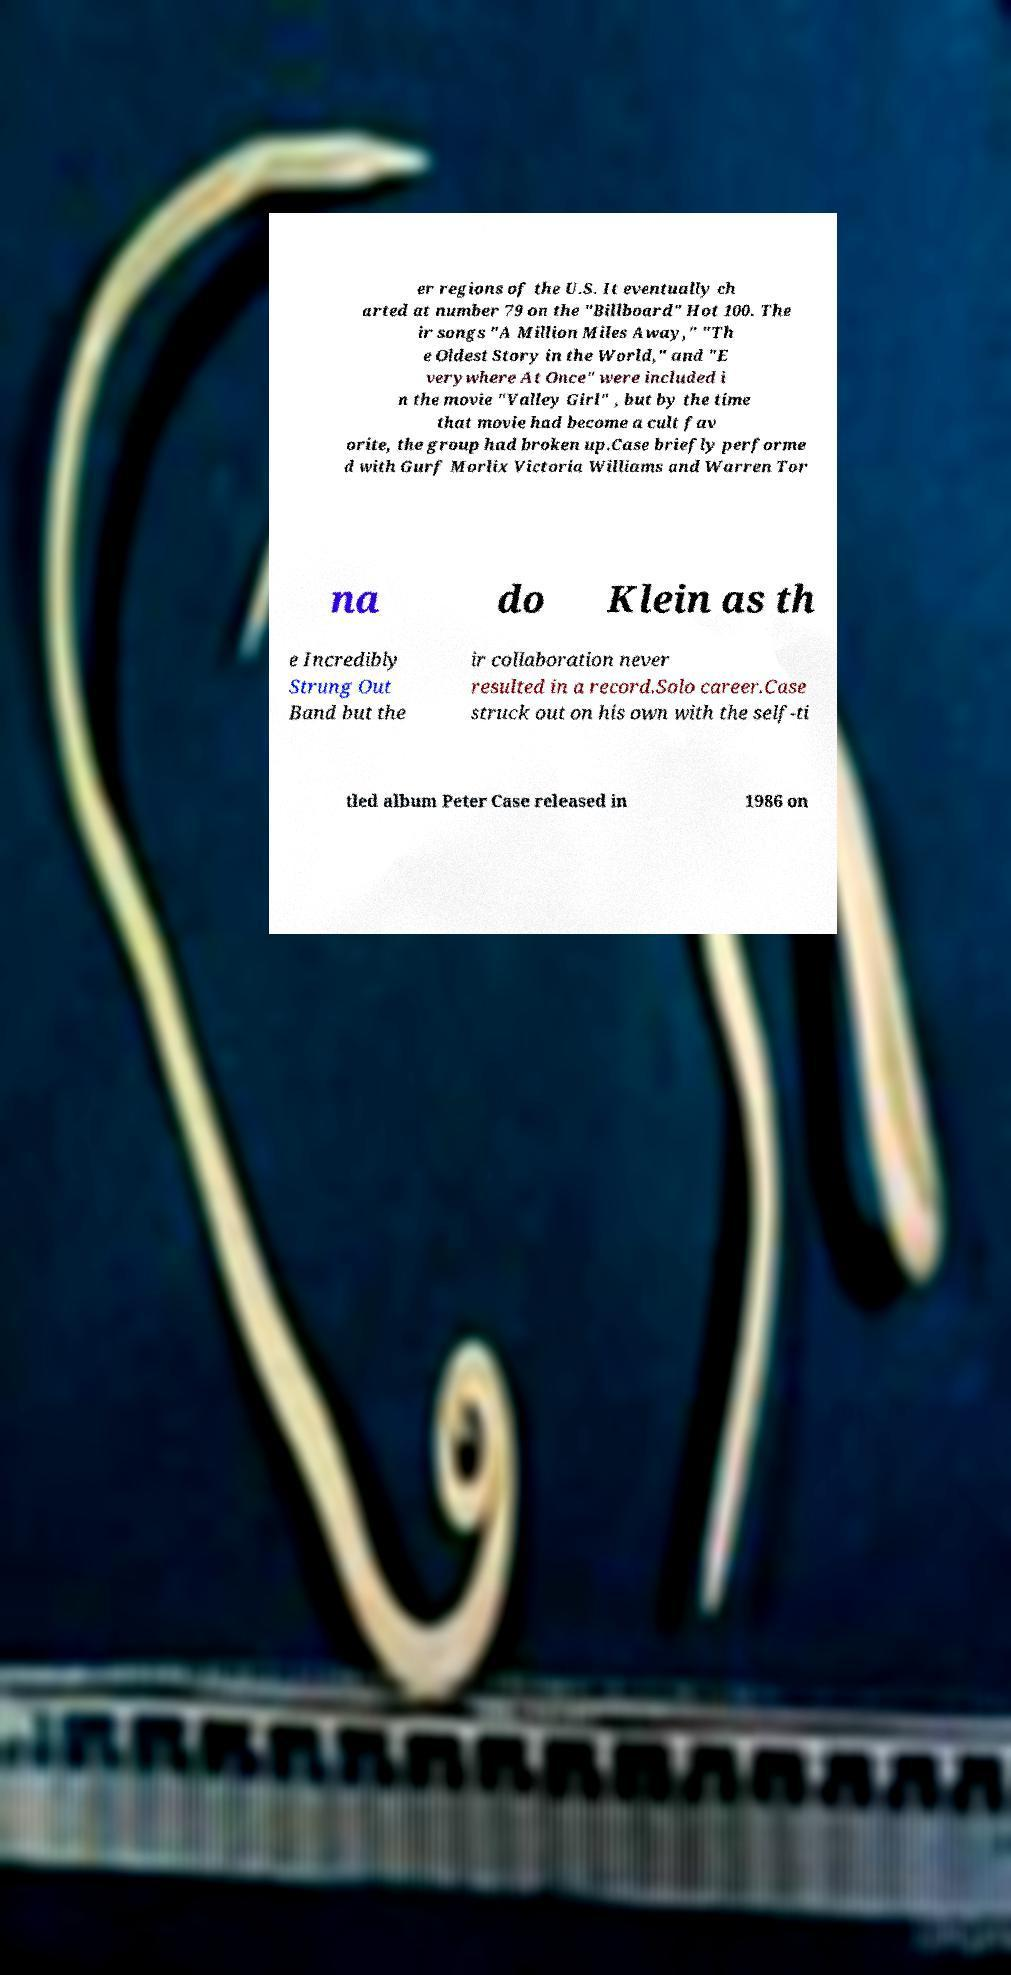Please identify and transcribe the text found in this image. er regions of the U.S. It eventually ch arted at number 79 on the "Billboard" Hot 100. The ir songs "A Million Miles Away," "Th e Oldest Story in the World," and "E verywhere At Once" were included i n the movie "Valley Girl" , but by the time that movie had become a cult fav orite, the group had broken up.Case briefly performe d with Gurf Morlix Victoria Williams and Warren Tor na do Klein as th e Incredibly Strung Out Band but the ir collaboration never resulted in a record.Solo career.Case struck out on his own with the self-ti tled album Peter Case released in 1986 on 